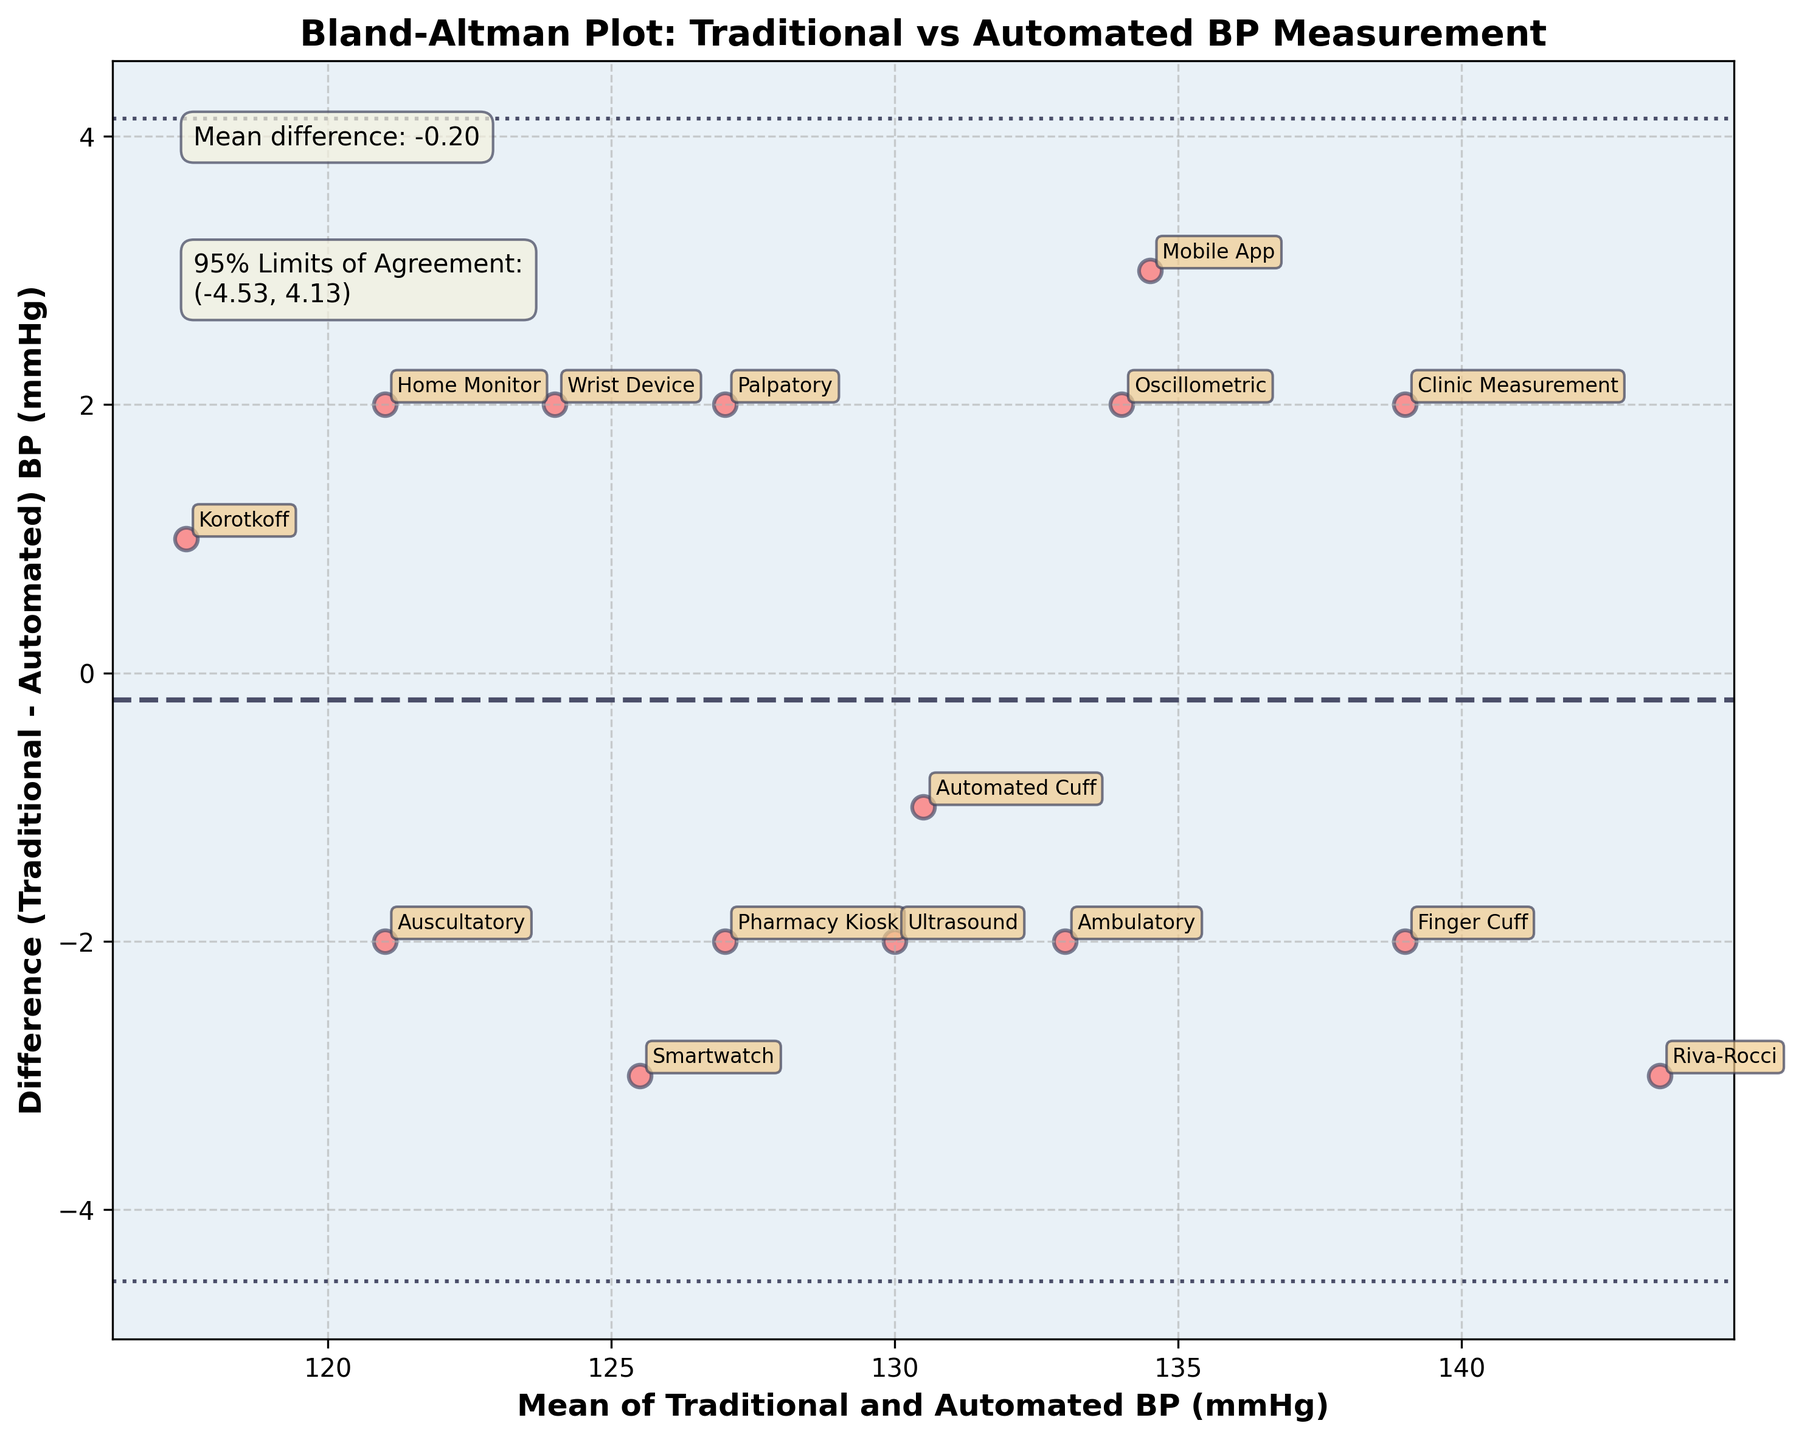what is the mean difference between Traditional and Automated BP measurements? The mean difference is indicated by the dashed line on the plot. Based on the annotation, it is clearly stated.
Answer: 0.60 what are the 95% limits of agreement? The 95% limits of agreement are shown by the dotted lines on the plot. They are also indicated in the annotation box in the top-left corner.
Answer: (-3.45, 4.65) which blood pressure measurement method has the highest mean value? The highest mean value can be estimated by looking at the data points furthest to the right on the x-axis. "Riva-Rocci" method has the highest mean value.
Answer: Riva-Rocci what's the mean of Traditional and Automated BP for the "Wrist Device" method? Locate the "Wrist Device" data point on the plot and find its position on the x-axis.
Answer: 124 which measurements have a positive difference (Traditional BP higher than Automated BP)? Data points above the mean difference line indicate traditional BP is higher than automated BP. Based on the plot, they are "Auscultatory," "Oscillometric," "Riva-Rocci," "Home Monitor," "Pharmacy Kiosk," and "Mobile App".
Answer: Auscultatory, Oscillometric, Riva-Rocci, Home Monitor, Pharmacy Kiosk, Mobile App what is the standard deviation of the differences between Traditional and Automated BP measurements? The standard deviation is implicit in calculating the 95% limits of agreement. The limits of agreement are mean difference ± 1.96 standard deviations. Rearranging the formula gives std_diff = (4.65 - (-3.45)) / (2*1.96) ≈ 2.090.
Answer: 2.09 do more data points lie above or below the mean difference line? By counting the data points on the plot, there are 8 data points above the mean difference line and 7 points below.
Answer: Above what is the difference (Traditional - Automated) for the "Korotkoff" method? Locate the "Korotkoff" data point on the plot and find its position on the y-axis.
Answer: 1 